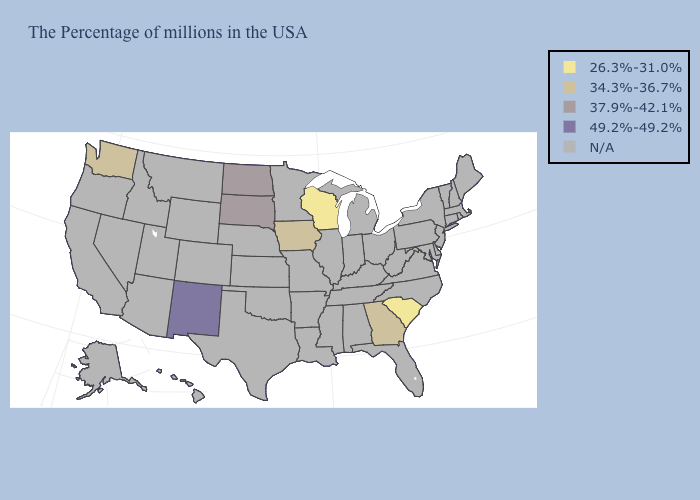Name the states that have a value in the range 34.3%-36.7%?
Answer briefly. Georgia, Iowa, Washington. What is the value of Maryland?
Be succinct. N/A. Name the states that have a value in the range 34.3%-36.7%?
Keep it brief. Georgia, Iowa, Washington. How many symbols are there in the legend?
Concise answer only. 5. Which states have the highest value in the USA?
Be succinct. New Mexico. Does Washington have the lowest value in the West?
Answer briefly. Yes. Name the states that have a value in the range N/A?
Answer briefly. Maine, Massachusetts, Rhode Island, New Hampshire, Vermont, Connecticut, New York, New Jersey, Delaware, Maryland, Pennsylvania, Virginia, North Carolina, West Virginia, Ohio, Florida, Michigan, Kentucky, Indiana, Alabama, Tennessee, Illinois, Mississippi, Louisiana, Missouri, Arkansas, Minnesota, Kansas, Nebraska, Oklahoma, Texas, Wyoming, Colorado, Utah, Montana, Arizona, Idaho, Nevada, California, Oregon, Alaska, Hawaii. Does North Dakota have the highest value in the USA?
Quick response, please. No. What is the value of Alaska?
Short answer required. N/A. Name the states that have a value in the range 37.9%-42.1%?
Answer briefly. South Dakota, North Dakota. Name the states that have a value in the range 26.3%-31.0%?
Concise answer only. South Carolina, Wisconsin. What is the value of Wyoming?
Give a very brief answer. N/A. 